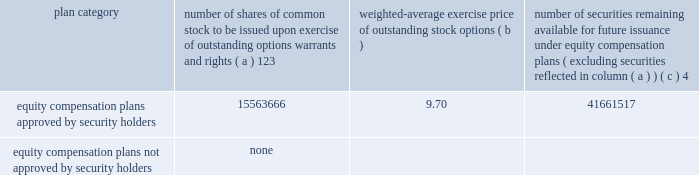Part iii item 10 .
Directors , executive officers and corporate governance the information required by this item is incorporated by reference to the 201celection of directors 201d section , the 201cdirector selection process 201d section , the 201ccode of conduct 201d section , the 201cprincipal committees of the board of directors 201d section , the 201caudit committee 201d section and the 201csection 16 ( a ) beneficial ownership reporting compliance 201d section of the proxy statement for the annual meeting of stockholders to be held on may 21 , 2015 ( the 201cproxy statement 201d ) , except for the description of our executive officers , which appears in part i of this report on form 10-k under the heading 201cexecutive officers of ipg . 201d new york stock exchange certification in 2014 , our chief executive officer provided the annual ceo certification to the new york stock exchange , as required under section 303a.12 ( a ) of the new york stock exchange listed company manual .
Item 11 .
Executive compensation the information required by this item is incorporated by reference to the 201cexecutive compensation 201d section , the 201cnon- management director compensation 201d section , the 201ccompensation discussion and analysis 201d section and the 201ccompensation and leadership talent committee report 201d section of the proxy statement .
Item 12 .
Security ownership of certain beneficial owners and management and related stockholder matters the information required by this item is incorporated by reference to the 201coutstanding shares and ownership of common stock 201d section of the proxy statement , except for information regarding the shares of common stock to be issued or which may be issued under our equity compensation plans as of december 31 , 2014 , which is provided in the table .
Equity compensation plan information plan category number of shares of common stock to be issued upon exercise of outstanding options , warrants and rights ( a ) 123 weighted-average exercise price of outstanding stock options number of securities remaining available for future issuance under equity compensation plans ( excluding securities reflected in column ( a ) ) equity compensation plans approved by security holders .
15563666 9.70 41661517 equity compensation plans not approved by security holders .
None 1 included a total of 5866475 performance-based share awards made under the 2009 and 2014 performance incentive plans representing the target number of shares of common stock to be issued to employees following the completion of the 2012-2014 performance period ( the 201c2014 ltip share awards 201d ) , the 2013-2015 performance period ( the 201c2015 ltip share awards 201d ) and the 2014-2016 performance period ( the 201c2016 ltip share awards 201d ) , respectively .
The computation of the weighted-average exercise price in column ( b ) of this table does not take the 2014 ltip share awards , the 2015 ltip share awards or the 2016 ltip share awards into account .
2 included a total of 98877 restricted share units and performance-based awards ( 201cshare unit awards 201d ) which may be settled in shares of common stock or cash .
The computation of the weighted-average exercise price in column ( b ) of this table does not take the share unit awards into account .
Each share unit award actually settled in cash will increase the number of shares of common stock available for issuance shown in column ( c ) .
3 ipg has issued restricted cash awards ( 201cperformance cash awards 201d ) , half of which shall be settled in shares of common stock and half of which shall be settled in cash .
Using the 2014 closing stock price of $ 20.77 , the awards which shall be settled in shares of common stock represent rights to an additional 2721405 shares .
These shares are not included in the table above .
4 included ( i ) 29045044 shares of common stock available for issuance under the 2014 performance incentive plan , ( ii ) 12181214 shares of common stock available for issuance under the employee stock purchase plan ( 2006 ) and ( iii ) 435259 shares of common stock available for issuance under the 2009 non-management directors 2019 stock incentive plan. .
Part iii item 10 .
Directors , executive officers and corporate governance the information required by this item is incorporated by reference to the 201celection of directors 201d section , the 201cdirector selection process 201d section , the 201ccode of conduct 201d section , the 201cprincipal committees of the board of directors 201d section , the 201caudit committee 201d section and the 201csection 16 ( a ) beneficial ownership reporting compliance 201d section of the proxy statement for the annual meeting of stockholders to be held on may 21 , 2015 ( the 201cproxy statement 201d ) , except for the description of our executive officers , which appears in part i of this report on form 10-k under the heading 201cexecutive officers of ipg . 201d new york stock exchange certification in 2014 , our chief executive officer provided the annual ceo certification to the new york stock exchange , as required under section 303a.12 ( a ) of the new york stock exchange listed company manual .
Item 11 .
Executive compensation the information required by this item is incorporated by reference to the 201cexecutive compensation 201d section , the 201cnon- management director compensation 201d section , the 201ccompensation discussion and analysis 201d section and the 201ccompensation and leadership talent committee report 201d section of the proxy statement .
Item 12 .
Security ownership of certain beneficial owners and management and related stockholder matters the information required by this item is incorporated by reference to the 201coutstanding shares and ownership of common stock 201d section of the proxy statement , except for information regarding the shares of common stock to be issued or which may be issued under our equity compensation plans as of december 31 , 2014 , which is provided in the following table .
Equity compensation plan information plan category number of shares of common stock to be issued upon exercise of outstanding options , warrants and rights ( a ) 123 weighted-average exercise price of outstanding stock options number of securities remaining available for future issuance under equity compensation plans ( excluding securities reflected in column ( a ) ) equity compensation plans approved by security holders .
15563666 9.70 41661517 equity compensation plans not approved by security holders .
None 1 included a total of 5866475 performance-based share awards made under the 2009 and 2014 performance incentive plans representing the target number of shares of common stock to be issued to employees following the completion of the 2012-2014 performance period ( the 201c2014 ltip share awards 201d ) , the 2013-2015 performance period ( the 201c2015 ltip share awards 201d ) and the 2014-2016 performance period ( the 201c2016 ltip share awards 201d ) , respectively .
The computation of the weighted-average exercise price in column ( b ) of this table does not take the 2014 ltip share awards , the 2015 ltip share awards or the 2016 ltip share awards into account .
2 included a total of 98877 restricted share units and performance-based awards ( 201cshare unit awards 201d ) which may be settled in shares of common stock or cash .
The computation of the weighted-average exercise price in column ( b ) of this table does not take the share unit awards into account .
Each share unit award actually settled in cash will increase the number of shares of common stock available for issuance shown in column ( c ) .
3 ipg has issued restricted cash awards ( 201cperformance cash awards 201d ) , half of which shall be settled in shares of common stock and half of which shall be settled in cash .
Using the 2014 closing stock price of $ 20.77 , the awards which shall be settled in shares of common stock represent rights to an additional 2721405 shares .
These shares are not included in the table above .
4 included ( i ) 29045044 shares of common stock available for issuance under the 2014 performance incentive plan , ( ii ) 12181214 shares of common stock available for issuance under the employee stock purchase plan ( 2006 ) and ( iii ) 435259 shares of common stock available for issuance under the 2009 non-management directors 2019 stock incentive plan. .
What is the total value of equity compensation plan approved by security holders , ( in millions ) ? 
Computations: ((15563666 * 9.70) / 1000000)
Answer: 150.96756. 